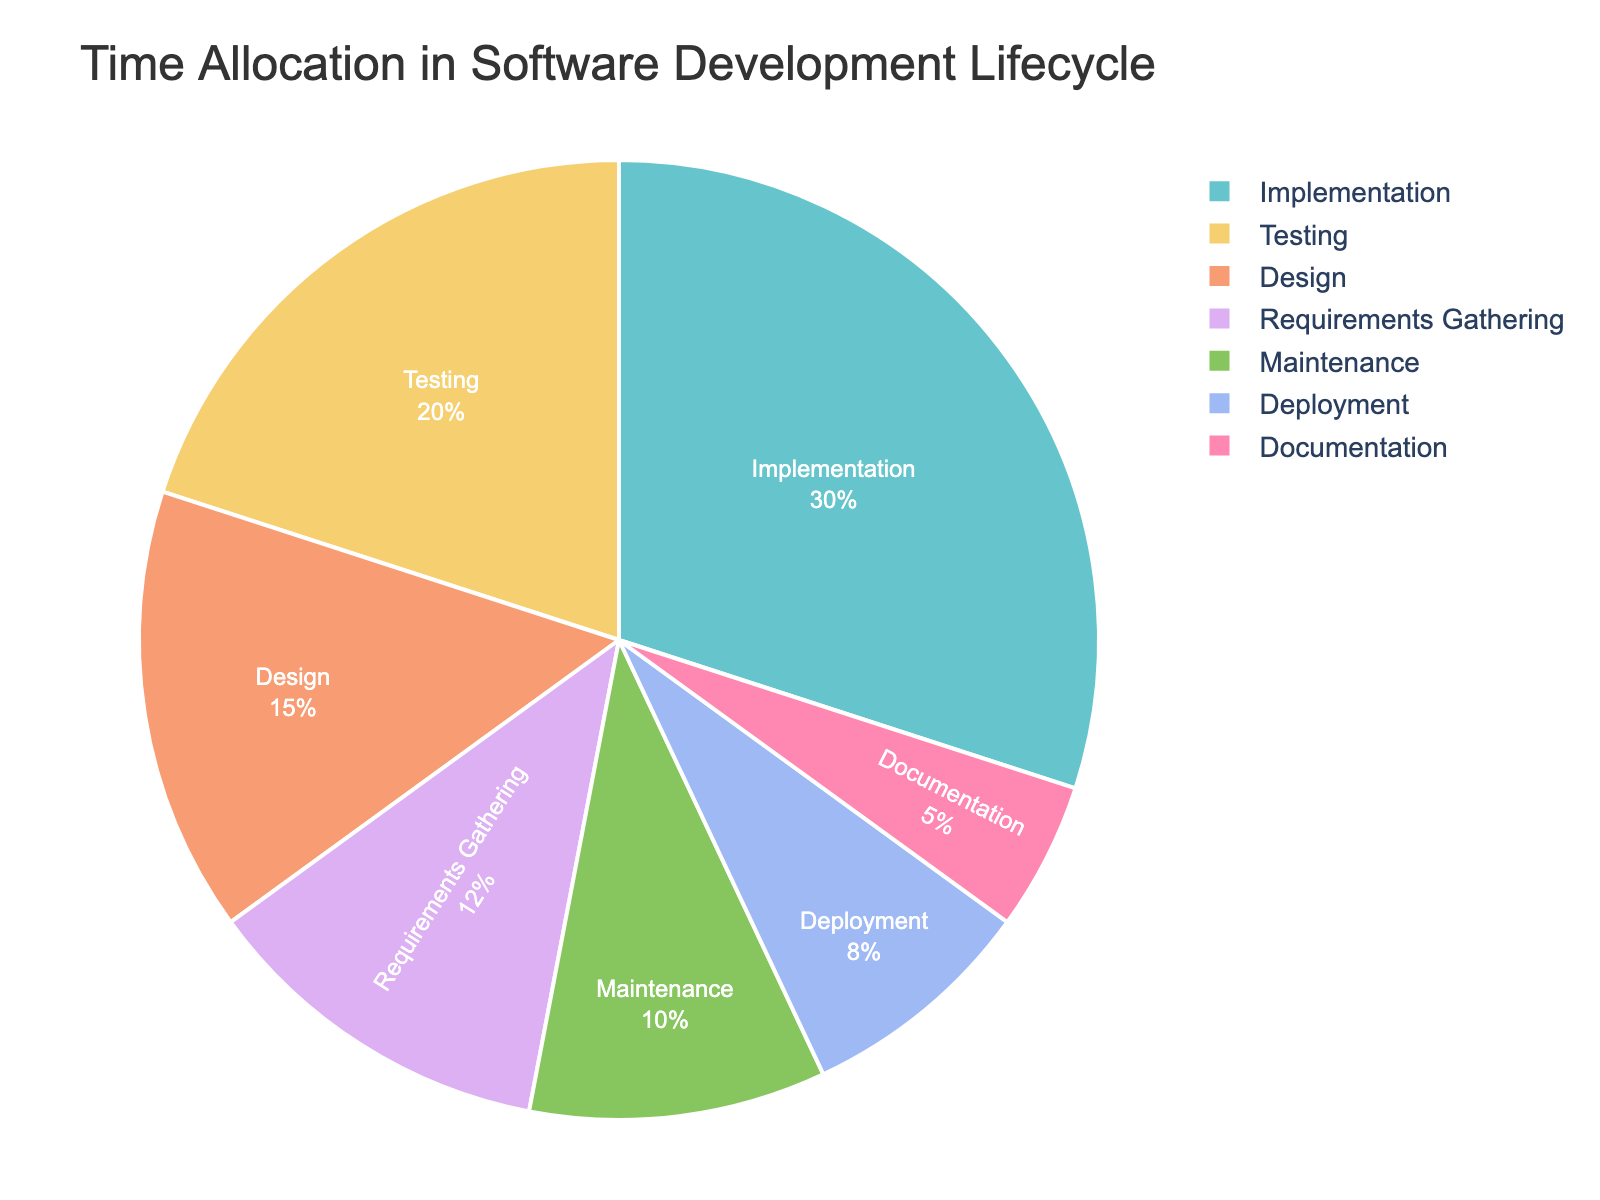Which phase takes up the most time in the software development lifecycle? The Implementation phase has the biggest slice in the pie chart, indicating it takes up the largest percentage of time.
Answer: Implementation What is the combined percentage of time allocated to Deployment and Maintenance? Deployment takes up 8% and Maintenance takes up 10% of the time. Adding these together (8% + 10%) gives 18%.
Answer: 18% Is more time allocated to Testing or Design? The chart shows that Testing takes up 20% and Design takes up 15%. Since 20% is greater than 15%, more time is allocated to Testing.
Answer: Testing How does the time spent on Documentation compare to the time spent on Deployment? The slice for Documentation is 5%, while Deployment is 8%. Since 8% is greater than 5%, more time is spent on Deployment than on Documentation.
Answer: Deployment Which two phases together account for more than half of the total time allocation? Implementation takes up 30% and Testing takes up 20%. Together, they account for 50% of the total time. Since 50% is exactly half, no other combination exceeds 50%. However, including a smaller slice like Requirements Gathering (12%) with Implementation reaches 42%, still below the threshold of "more than half."
Answer: Not applicable What is the ratio of time spent on Implementation to the time spent on Documentation? Implementation takes up 30%, and Documentation takes up 5%. The ratio of Implementation to Documentation is 30:5, which simplifies to 6:1.
Answer: 6:1 Which phase takes less time, Maintenance or Requirements Gathering? Maintenance takes 10% and Requirements Gathering takes 12%. Since 10% is less than 12%, Maintenance takes less time.
Answer: Maintenance Calculate the total percentage time allocated to non-productive phases like Maintenance and Documentation. Maintenance accounts for 10%, and Documentation accounts for 5%. Adding these together (10% + 5%) gives 15%.
Answer: 15% What percentage of the total time is dedicated to phases before the actual software creation (Implementation)? The phases before Implementation are Requirements Gathering (12%) and Design (15%). Adding these together gives 12% + 15% = 27%.
Answer: 27% 